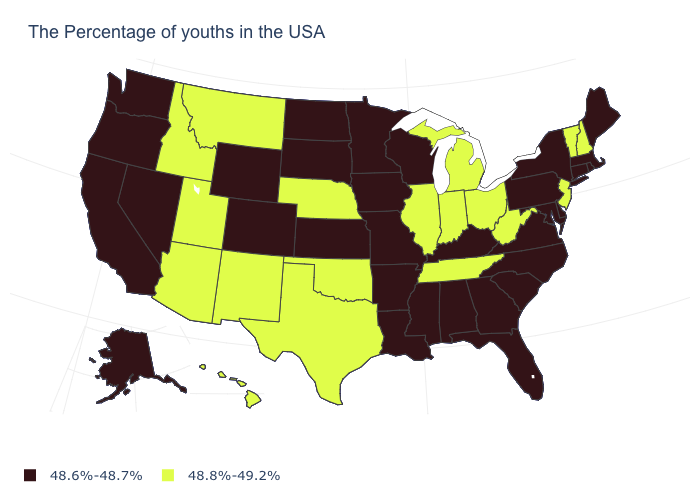Among the states that border Connecticut , which have the highest value?
Give a very brief answer. Massachusetts, Rhode Island, New York. What is the value of Maine?
Give a very brief answer. 48.6%-48.7%. What is the value of Idaho?
Give a very brief answer. 48.8%-49.2%. Among the states that border Washington , does Idaho have the highest value?
Quick response, please. Yes. Which states have the lowest value in the South?
Keep it brief. Delaware, Maryland, Virginia, North Carolina, South Carolina, Florida, Georgia, Kentucky, Alabama, Mississippi, Louisiana, Arkansas. Name the states that have a value in the range 48.6%-48.7%?
Short answer required. Maine, Massachusetts, Rhode Island, Connecticut, New York, Delaware, Maryland, Pennsylvania, Virginia, North Carolina, South Carolina, Florida, Georgia, Kentucky, Alabama, Wisconsin, Mississippi, Louisiana, Missouri, Arkansas, Minnesota, Iowa, Kansas, South Dakota, North Dakota, Wyoming, Colorado, Nevada, California, Washington, Oregon, Alaska. Does Oklahoma have a higher value than Nebraska?
Concise answer only. No. Name the states that have a value in the range 48.8%-49.2%?
Keep it brief. New Hampshire, Vermont, New Jersey, West Virginia, Ohio, Michigan, Indiana, Tennessee, Illinois, Nebraska, Oklahoma, Texas, New Mexico, Utah, Montana, Arizona, Idaho, Hawaii. What is the value of Virginia?
Be succinct. 48.6%-48.7%. Does the map have missing data?
Short answer required. No. What is the highest value in states that border New Jersey?
Be succinct. 48.6%-48.7%. What is the value of Georgia?
Write a very short answer. 48.6%-48.7%. Among the states that border Alabama , does Florida have the lowest value?
Quick response, please. Yes. Does Illinois have the highest value in the USA?
Keep it brief. Yes. Name the states that have a value in the range 48.8%-49.2%?
Keep it brief. New Hampshire, Vermont, New Jersey, West Virginia, Ohio, Michigan, Indiana, Tennessee, Illinois, Nebraska, Oklahoma, Texas, New Mexico, Utah, Montana, Arizona, Idaho, Hawaii. 